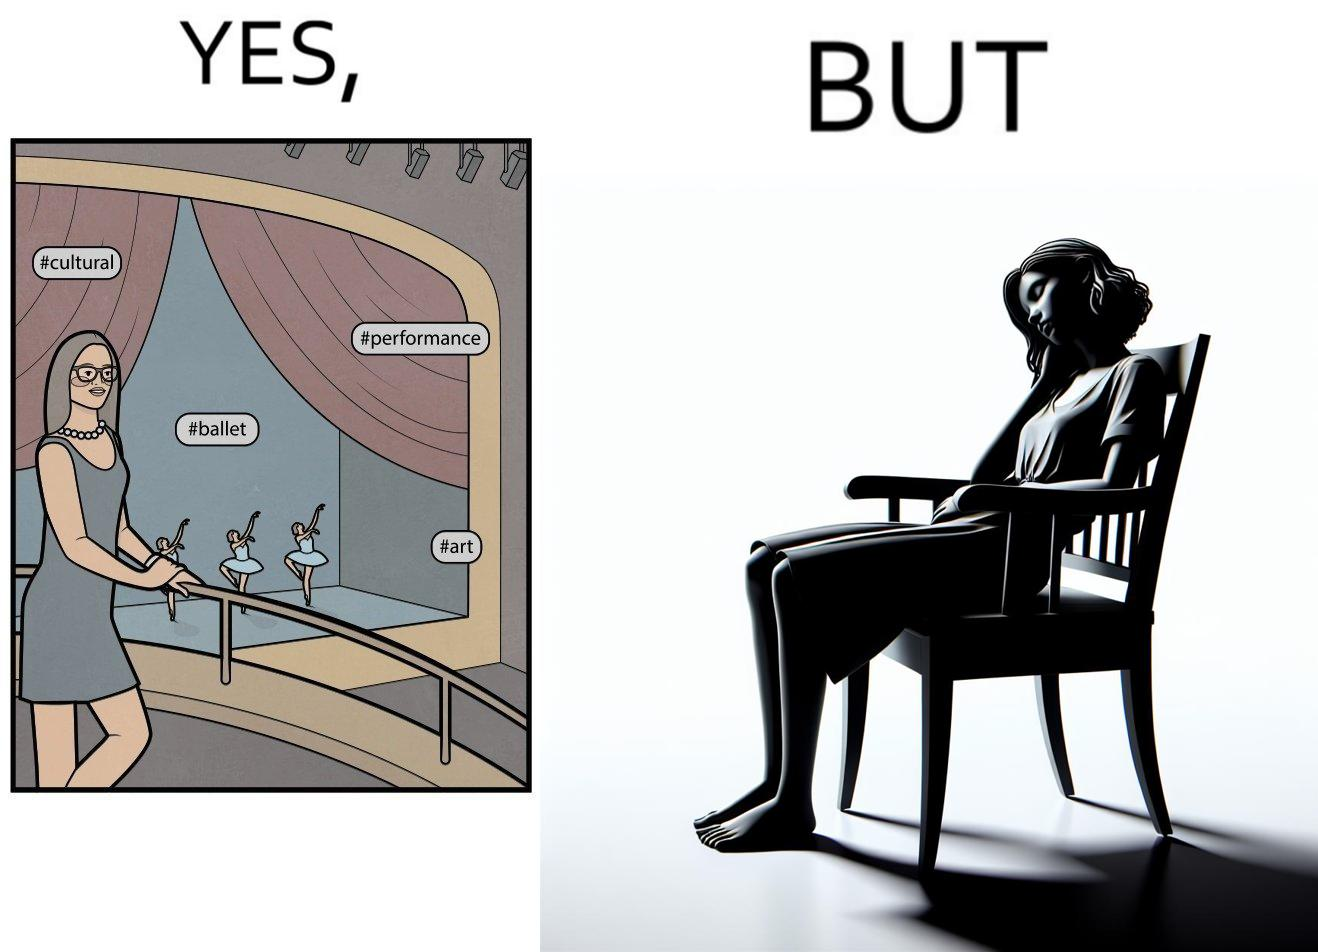Describe what you see in this image. The image is ironic, because in the first image the woman is trying to show off how much she likes ballet dance performance by posting a photo attending some program but in the same program she is seen sleeping on the chair 